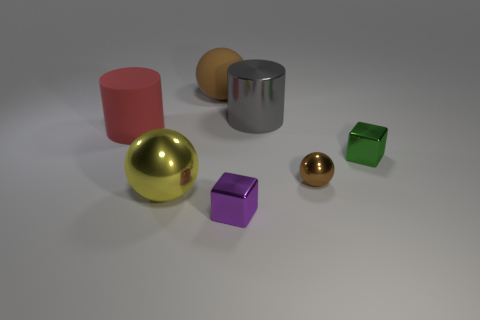How many red blocks are there? 0 